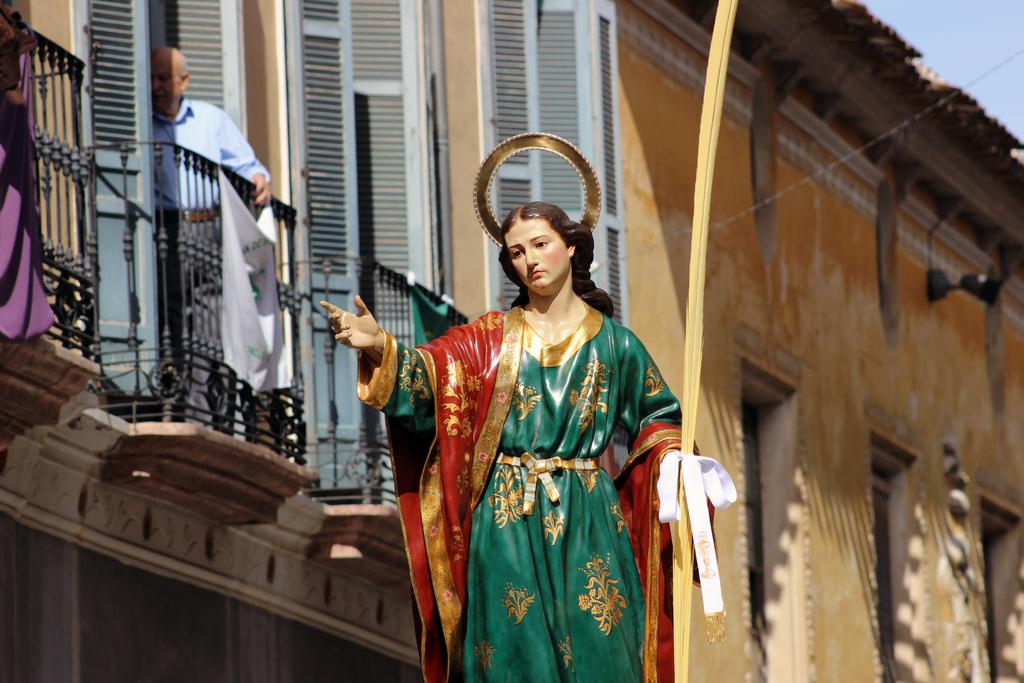What is the main subject of the image? There is a statue of a person in the image. What can be seen in the background of the image? There is a building in the background of the image. Where is the man located in the image? The man is standing behind a railing on the left side of the image. What is visible in the top right corner of the image? The sky is visible in the top right corner of the image. What type of cloth is draped over the dinosaurs in the image? There are no dinosaurs present in the image, and therefore no cloth can be draped over them. 